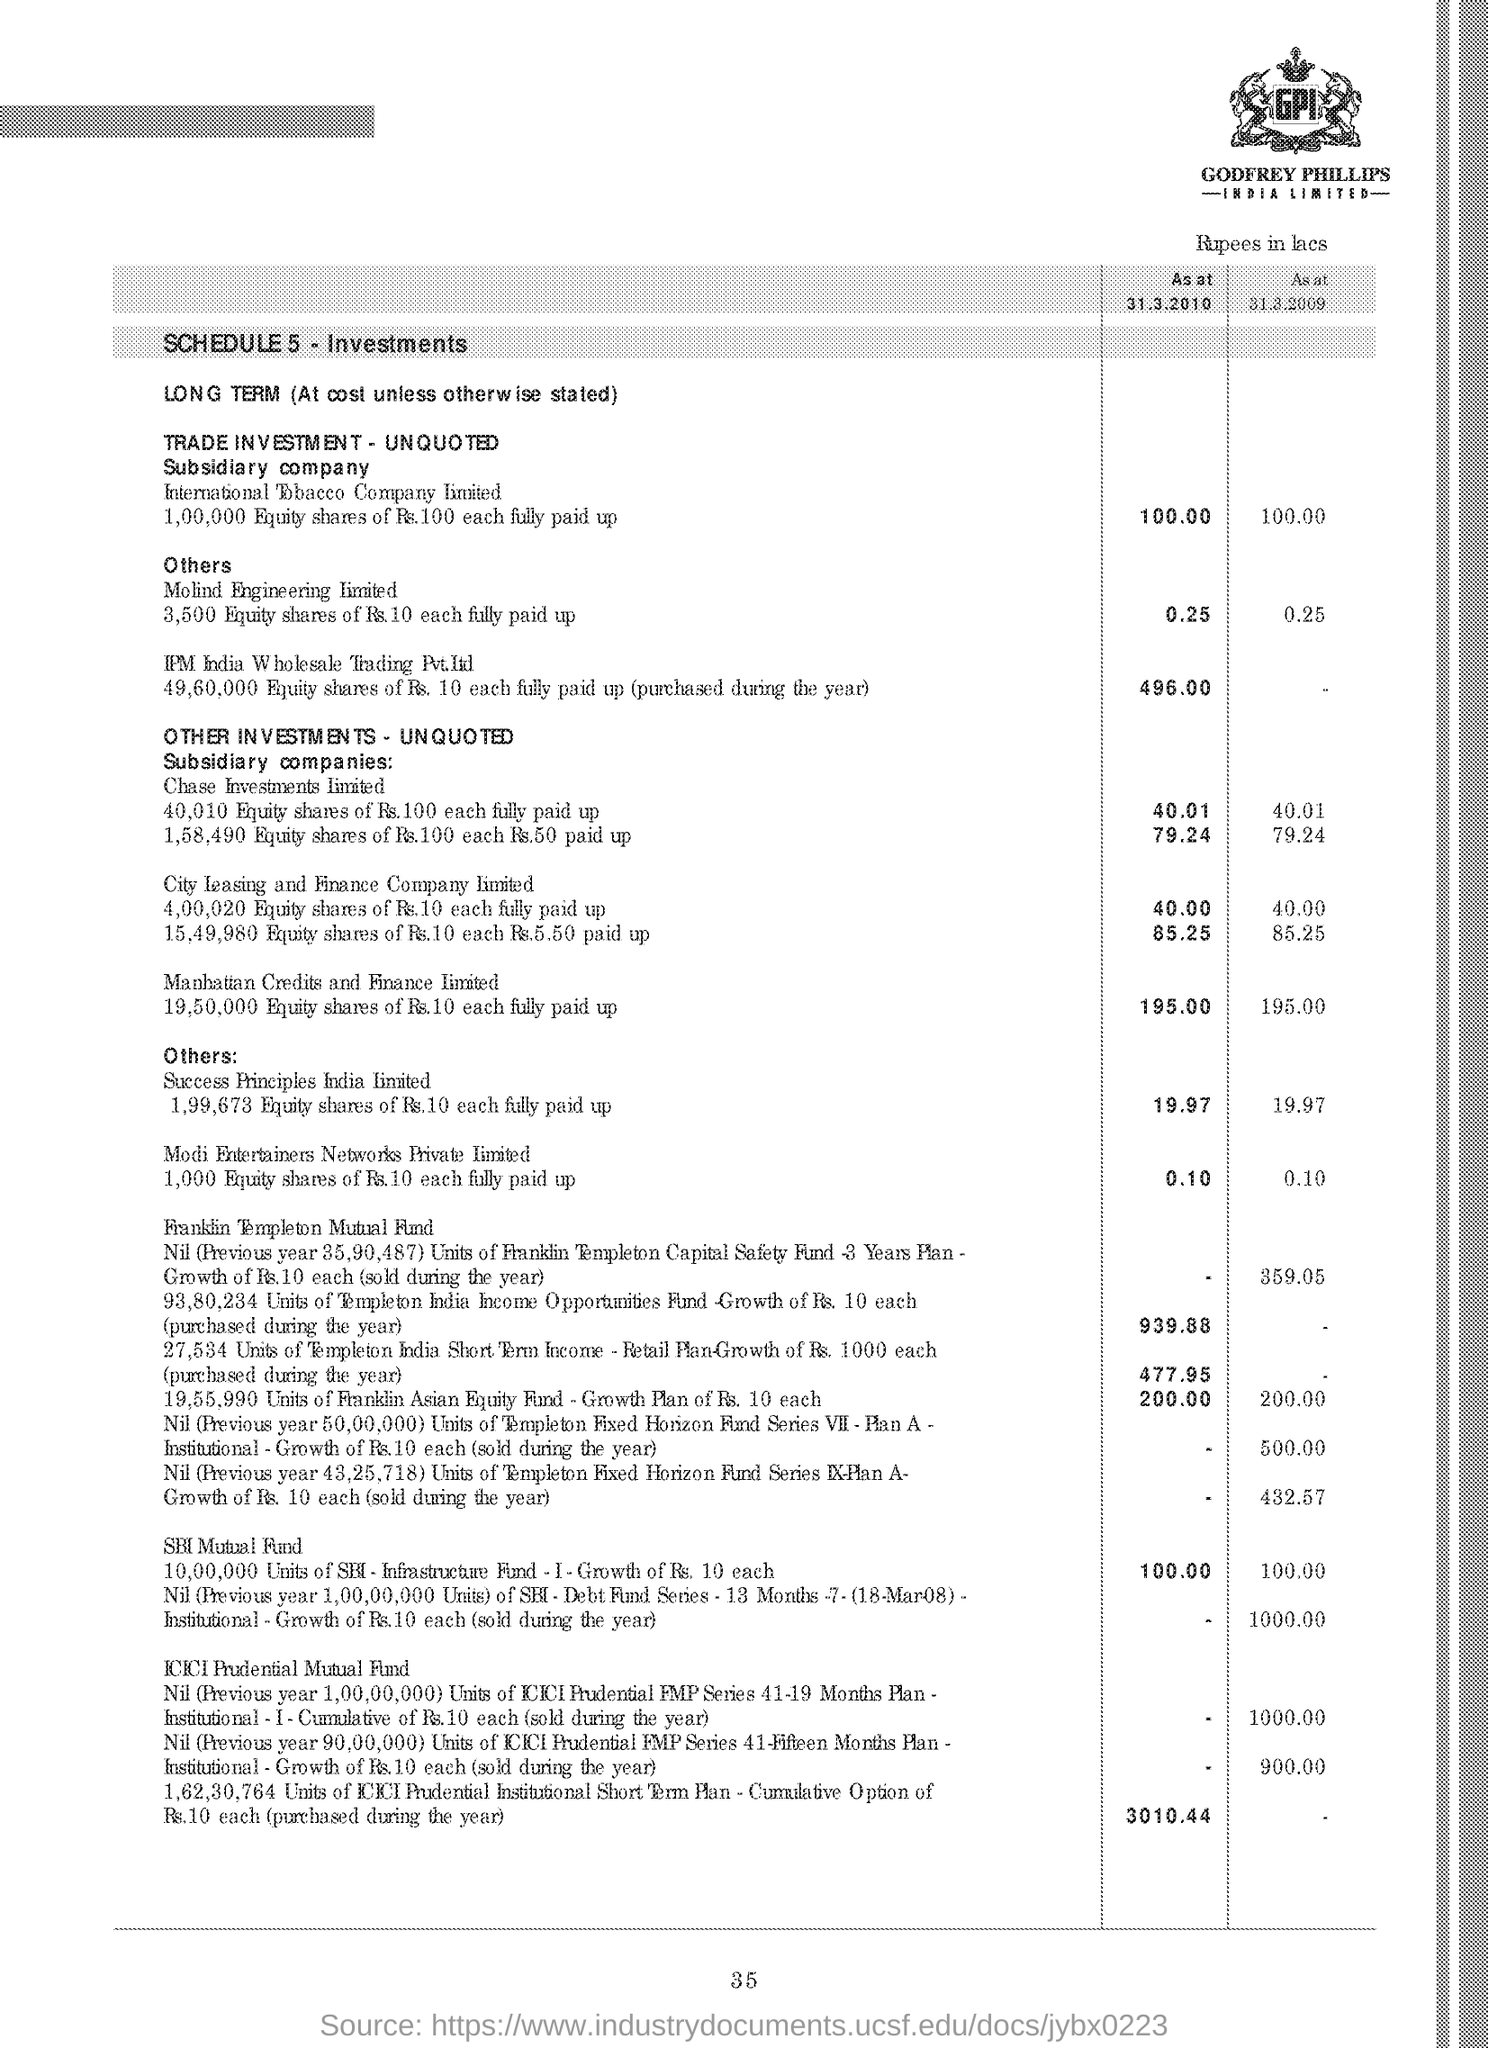What is the schedule number as per document?
Give a very brief answer. 5. What is the amount shown as per table for SBI Mutal Fund as on 31.3.2010
Your answer should be very brief. 100.00. For which period is there no amount in the table for IPM India Wholesale Trading Pvt. Ltd.
Your answer should be compact. 31.3.2009. 